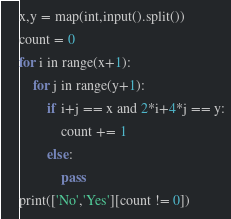<code> <loc_0><loc_0><loc_500><loc_500><_Python_>x,y = map(int,input().split())
count = 0
for i in range(x+1):
    for j in range(y+1):
        if i+j == x and 2*i+4*j == y:
            count += 1
        else:
            pass
print(['No','Yes'][count != 0])</code> 